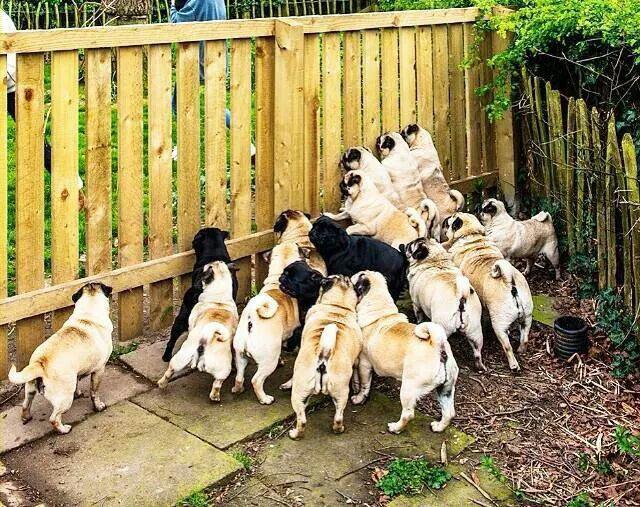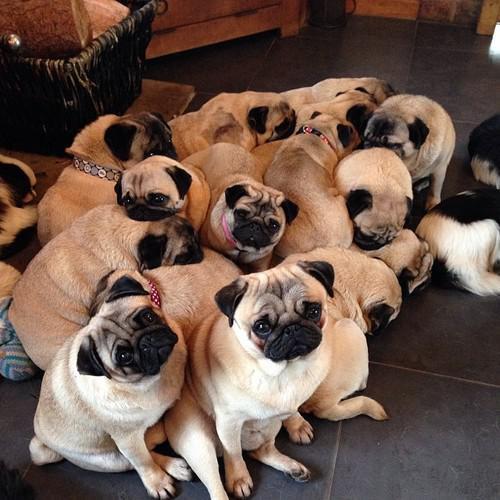The first image is the image on the left, the second image is the image on the right. Considering the images on both sides, is "Pugs are huddled together on a gray tiled floor" valid? Answer yes or no. Yes. 